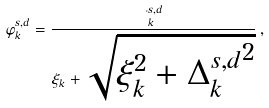<formula> <loc_0><loc_0><loc_500><loc_500>\varphi ^ { s , d } _ { k } = \frac { \Delta ^ { s , d } _ { k } } { \xi _ { k } + \sqrt { \xi _ { k } ^ { 2 } + { \Delta ^ { s , d } _ { k } } ^ { 2 } } } \, ,</formula> 